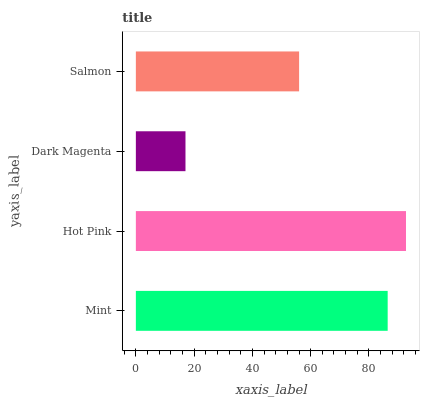Is Dark Magenta the minimum?
Answer yes or no. Yes. Is Hot Pink the maximum?
Answer yes or no. Yes. Is Hot Pink the minimum?
Answer yes or no. No. Is Dark Magenta the maximum?
Answer yes or no. No. Is Hot Pink greater than Dark Magenta?
Answer yes or no. Yes. Is Dark Magenta less than Hot Pink?
Answer yes or no. Yes. Is Dark Magenta greater than Hot Pink?
Answer yes or no. No. Is Hot Pink less than Dark Magenta?
Answer yes or no. No. Is Mint the high median?
Answer yes or no. Yes. Is Salmon the low median?
Answer yes or no. Yes. Is Dark Magenta the high median?
Answer yes or no. No. Is Mint the low median?
Answer yes or no. No. 